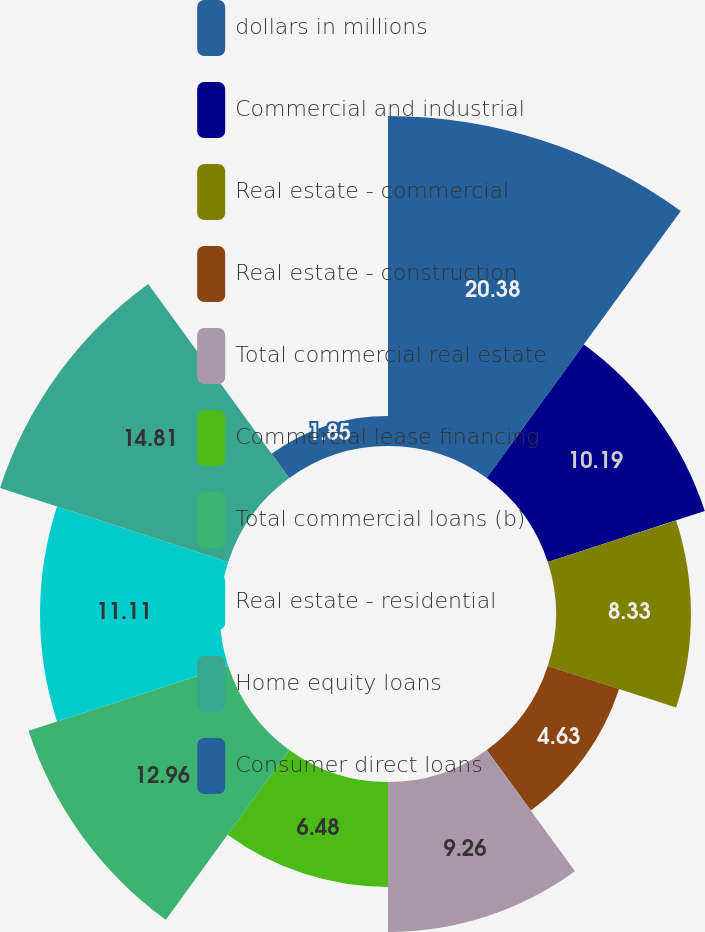Convert chart. <chart><loc_0><loc_0><loc_500><loc_500><pie_chart><fcel>dollars in millions<fcel>Commercial and industrial<fcel>Real estate - commercial<fcel>Real estate - construction<fcel>Total commercial real estate<fcel>Commercial lease financing<fcel>Total commercial loans (b)<fcel>Real estate - residential<fcel>Home equity loans<fcel>Consumer direct loans<nl><fcel>20.37%<fcel>10.19%<fcel>8.33%<fcel>4.63%<fcel>9.26%<fcel>6.48%<fcel>12.96%<fcel>11.11%<fcel>14.81%<fcel>1.85%<nl></chart> 